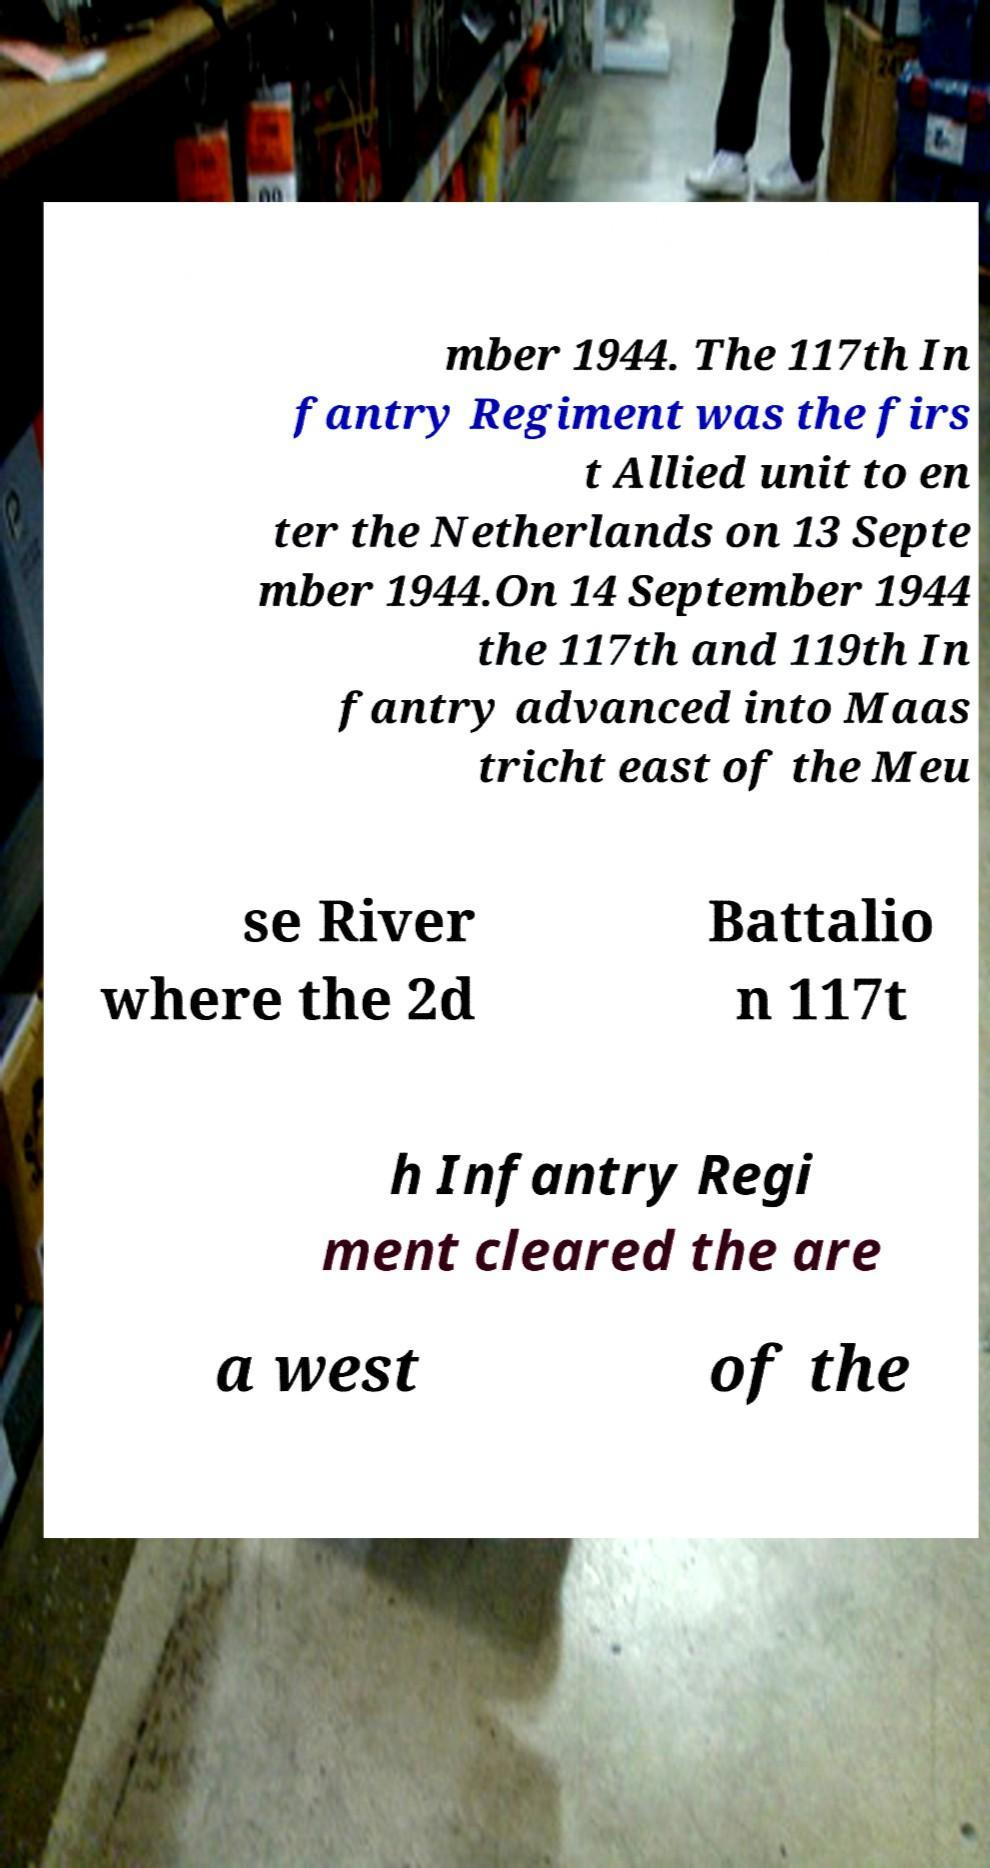Could you extract and type out the text from this image? mber 1944. The 117th In fantry Regiment was the firs t Allied unit to en ter the Netherlands on 13 Septe mber 1944.On 14 September 1944 the 117th and 119th In fantry advanced into Maas tricht east of the Meu se River where the 2d Battalio n 117t h Infantry Regi ment cleared the are a west of the 